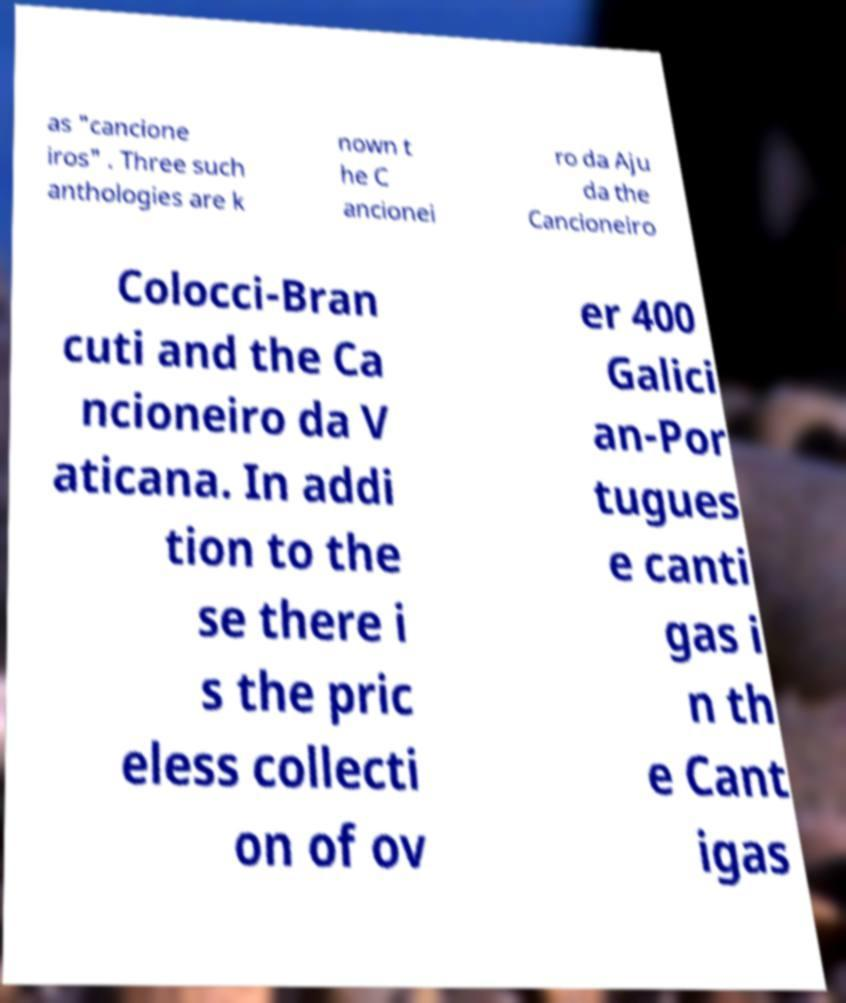What messages or text are displayed in this image? I need them in a readable, typed format. as "cancione iros" . Three such anthologies are k nown t he C ancionei ro da Aju da the Cancioneiro Colocci-Bran cuti and the Ca ncioneiro da V aticana. In addi tion to the se there i s the pric eless collecti on of ov er 400 Galici an-Por tugues e canti gas i n th e Cant igas 